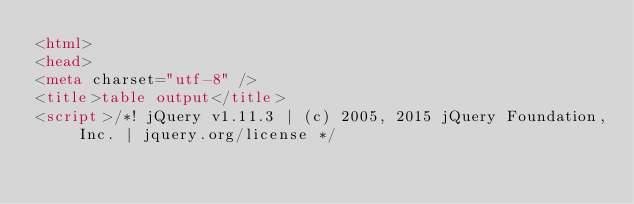Convert code to text. <code><loc_0><loc_0><loc_500><loc_500><_HTML_><html>
<head>
<meta charset="utf-8" />
<title>table output</title>
<script>/*! jQuery v1.11.3 | (c) 2005, 2015 jQuery Foundation, Inc. | jquery.org/license */</code> 